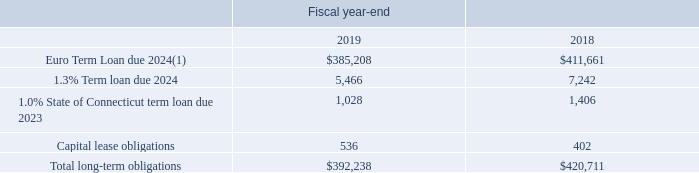Long-term obligations consist of the following (in thousands):
(1) Net of debt issuance costs of $6.4 million and $11.2 million at September 28, 2019 and September 29, 2018, respectively.
What does the Euro Term Loan due 2024 consist of? Net of debt issuance costs of $6.4 million and $11.2 million at september 28, 2019 and september 29, 2018, respectively. What was the Total long-term obligations in 2019?
Answer scale should be: thousand. $392,238. In which years was Total long-term obligations calculated? 2019, 2018. In which year was the 1.0% State of Connecticut term loan due 2023 larger? 1,406>1,028
Answer: 2018. What was the change in Capital lease obligations from 2018 to 2019?
Answer scale should be: thousand. 536-402
Answer: 134. What was the percentage change in Capital lease obligations from 2018 to 2019?
Answer scale should be: percent. (536-402)/402
Answer: 33.33. 